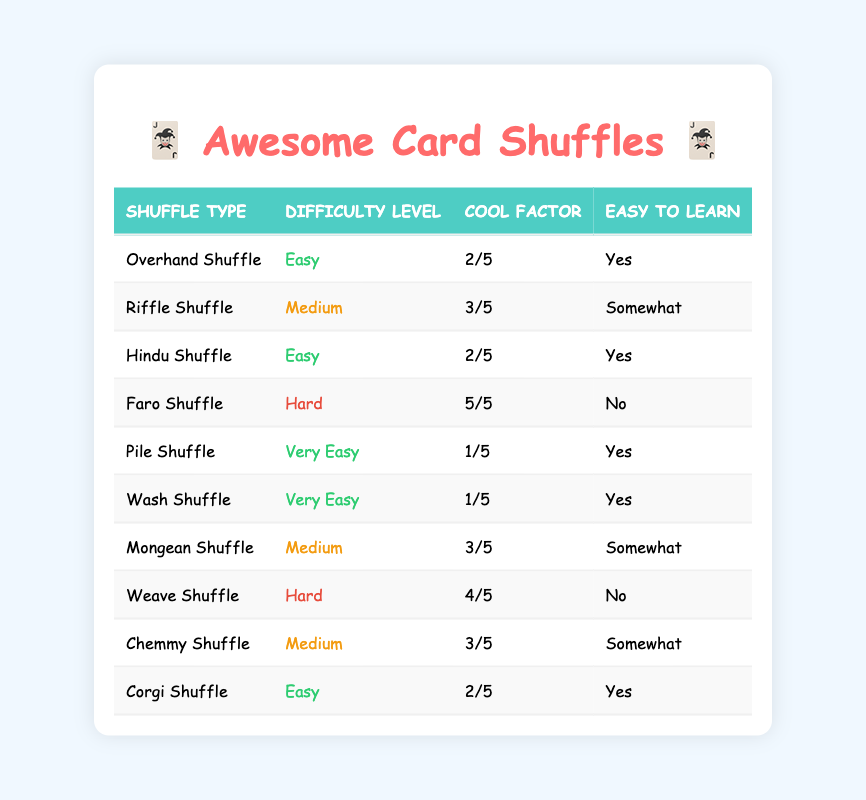What types of shuffles are classified as "Easy"? By looking at the "Difficulty Level" column, the shuffles marked as "Easy" are Overhand Shuffle, Hindu Shuffle, and Corgi Shuffle.
Answer: Overhand Shuffle, Hindu Shuffle, Corgi Shuffle Which shuffle has the highest cool factor? Checking the "Cool Factor" column, the Faro Shuffle has the highest rating of 5/5.
Answer: Faro Shuffle How many shuffles are classified as "Medium"? In the "Difficulty Level" column, the shuffles marked as "Medium" are Riffle Shuffle, Mongean Shuffle, and Chemmy Shuffle. There are three such shuffles.
Answer: 3 Are the Wash Shuffle and Pile Shuffle both easy to learn? Both the Wash Shuffle and Pile Shuffle are marked as "Yes" under the "Easy to Learn" column, confirming their ease of learning.
Answer: Yes What is the average cool factor of the shuffles classified as "Hard"? The cool factors for the "Hard" shuffles (Faro Shuffle and Weave Shuffle) are 5/5 and 4/5 respectively. To find the average, first convert these fractions: 5/5 = 1.0 and 4/5 = 0.8. The sum is 1.0 + 0.8 = 1.8, and then divide by 2 giving 1.8/2 = 0.9, which corresponds to 4.5 on the scale of 5.
Answer: 4.5 Which shuffle is both Very Easy and easy to learn? From the table, both the Pile Shuffle and Wash Shuffle are classified as "Very Easy" and have "Yes" for "Easy to Learn," meaning they meet both criteria.
Answer: Pile Shuffle, Wash Shuffle 